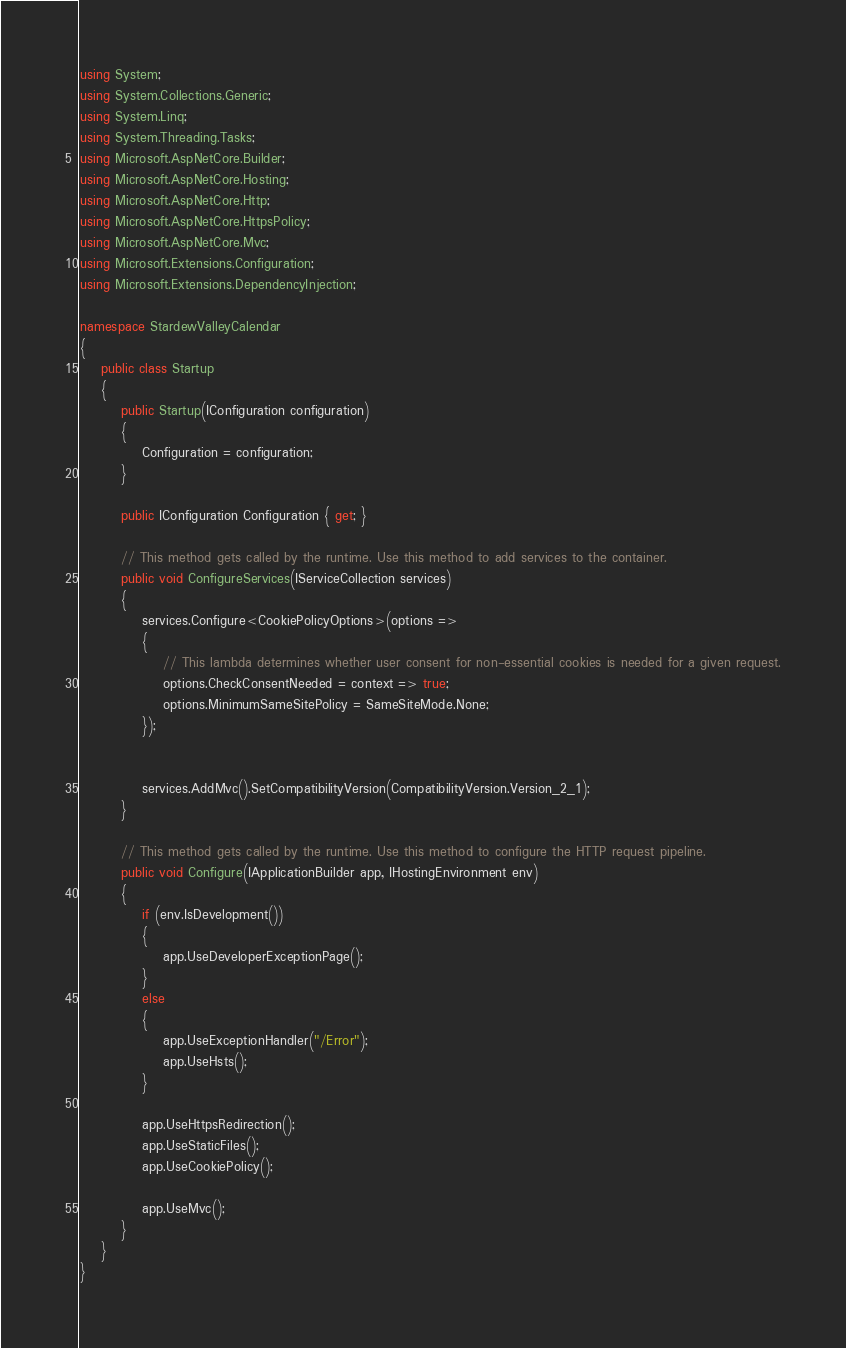Convert code to text. <code><loc_0><loc_0><loc_500><loc_500><_C#_>using System;
using System.Collections.Generic;
using System.Linq;
using System.Threading.Tasks;
using Microsoft.AspNetCore.Builder;
using Microsoft.AspNetCore.Hosting;
using Microsoft.AspNetCore.Http;
using Microsoft.AspNetCore.HttpsPolicy;
using Microsoft.AspNetCore.Mvc;
using Microsoft.Extensions.Configuration;
using Microsoft.Extensions.DependencyInjection;

namespace StardewValleyCalendar
{
    public class Startup
    {
        public Startup(IConfiguration configuration)
        {
            Configuration = configuration;
        }

        public IConfiguration Configuration { get; }

        // This method gets called by the runtime. Use this method to add services to the container.
        public void ConfigureServices(IServiceCollection services)
        {
            services.Configure<CookiePolicyOptions>(options =>
            {
                // This lambda determines whether user consent for non-essential cookies is needed for a given request.
                options.CheckConsentNeeded = context => true;
                options.MinimumSameSitePolicy = SameSiteMode.None;
            });


            services.AddMvc().SetCompatibilityVersion(CompatibilityVersion.Version_2_1);
        }

        // This method gets called by the runtime. Use this method to configure the HTTP request pipeline.
        public void Configure(IApplicationBuilder app, IHostingEnvironment env)
        {
            if (env.IsDevelopment())
            {
                app.UseDeveloperExceptionPage();
            }
            else
            {
                app.UseExceptionHandler("/Error");
                app.UseHsts();
            }

            app.UseHttpsRedirection();
            app.UseStaticFiles();
            app.UseCookiePolicy();

            app.UseMvc();
        }
    }
}
</code> 